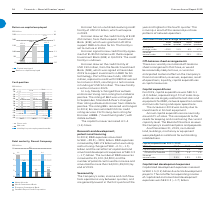According to Lm Ericsson Telephone's financial document, Which quarter has lowest in sales, income and cash flow from operations? According to the financial document, First quarter. The relevant text states: "between quarters, and are generally lowest in the first quarter of the between quarters, and are generally lowest in the first quarter of the..." Also, What is the share of annual sales in third quarter? According to the financial document, 25%. The relevant text states: "2022. Ericsson drew on the credit facility of EUR 250 million, from the European Investment Bank (EIB), which was granted in 2018 to support R&D activit..." Also, What is the share of annual sales in fourth quarter? According to the financial document, 29%. The relevant text states: "–25% 11% 4% 17% Share of annual sales 22% 24% 25% 29%..." Also, can you calculate: What is the change in share of annual sales between first quarter and second quarter? Based on the calculation: 24%-22%, the result is 2 (percentage). This is based on the information: "ange, sales –25% 11% 4% 17% Share of annual sales 22% 24% 25% 29% , sales –25% 11% 4% 17% Share of annual sales 22% 24% 25% 29%..." The key data points involved are: 22, 24. Also, can you calculate: What is the total share of annual sales for the second half of the year? Based on the calculation: 25%+29%, the result is 54 (percentage). This is based on the information: "Sequential change, sales –25% 11% 4% 17% Share of annual sales 22% 24% 25% 29% –25% 11% 4% 17% Share of annual sales 22% 24% 25% 29%..." The key data points involved are: 25, 29. Also, can you calculate: What is the change in sequential change of sales between second and third quarter? Based on the calculation: 11-4, the result is 7 (percentage). This is based on the information: "Sequential change, sales –25% 11% 4% 17% Share of annual sales 22% 24% 25% 29% table outlook. The capital turnover remained at 1.4 (1.4) times...." The key data points involved are: 11, 4. 